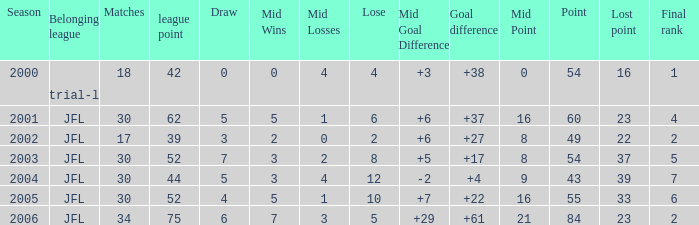Calculate the average loss when lost points exceed 16, goal difference is less than 37, and the total points are under 43. None. 